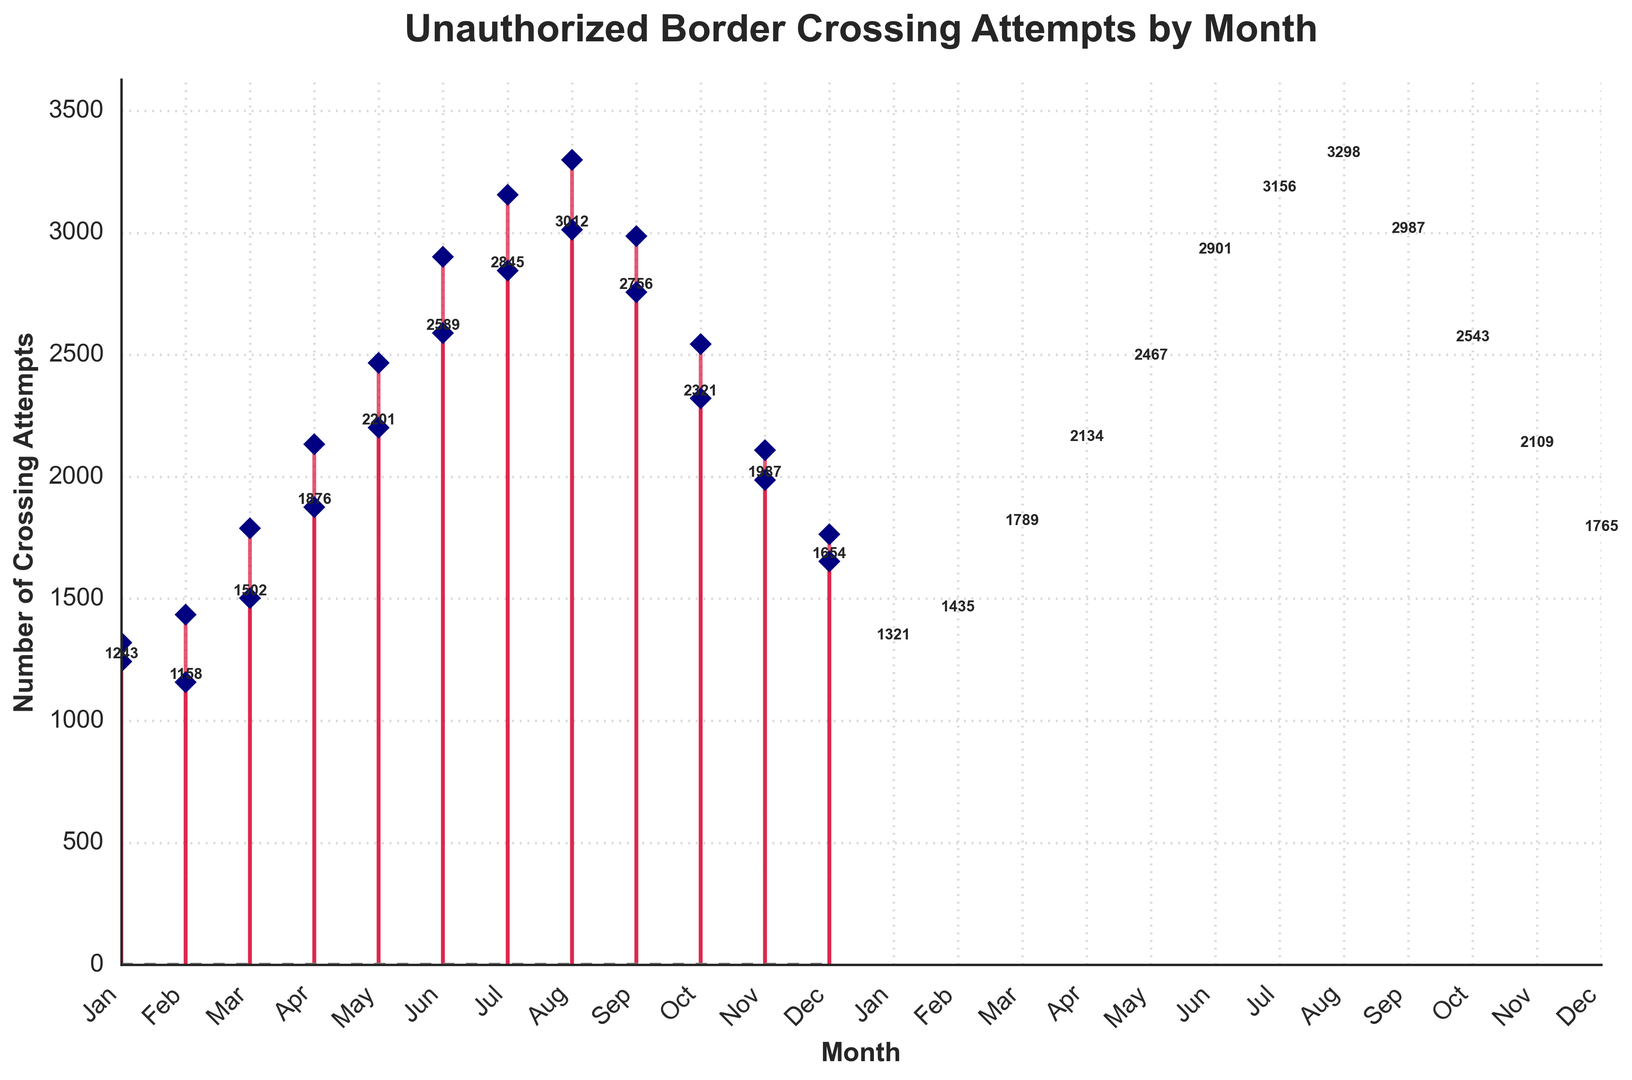What is the total number of unauthorized border crossing attempts detected in January over the two years? To find the total number of attempts in January for both years, sum the values for January in each year: 1243 (Jan, Year 1) + 1321 (Jan, Year 2) = 2564
Answer: 2564 In which month was the highest number of unauthorized border crossing attempts detected? Look for the month with the highest value on the graph. July (Year 2) has the highest peak with 3298 attempts based on the given data.
Answer: August How many more unauthorized border crossing attempts were detected in June compared to December in Year 1? For June (2589) and December (1654) in Year 1, the difference is 2589 - 1654 = 935
Answer: 935 Which month showed the least number of unauthorized border crossing attempts and what is that number? Identify the lowest marker on the graph. February (Year 1) with a value of 1158 is the lowest.
Answer: February with 1158 What was the average number of unauthorized border crossing attempts in the second half of Year 2 (July to December)? Sum the values from July to December in Year 2 (3156 + 3298 + 2987 + 2543 + 2109 + 1765), then divide by 6. The sum is 15858 ÷ 6 ≈ 2643.
Answer: Approximately 2643 Was there an overall increasing or decreasing trend in unauthorized border crossings from January to December each year? Observe the overall direction of the markers from January to December in both years. Both years show an increasing trend until the middle year (June/July), followed by a decline.
Answer: Increasing then decreasing By how much did the number of border crossing attempts increase from March to April in Year 2? April (2134) - March (1789) gives the increase of 2134 - 1789 = 345
Answer: 345 Which month in Year 1 had the closest number of unauthorized border crossings compared to September in Year 2? Compare the value for September in Year 2 (2987) to other months in Year 1 and find the closest value. August in Year 1 has 3012 which is closest to 2987.
Answer: August 